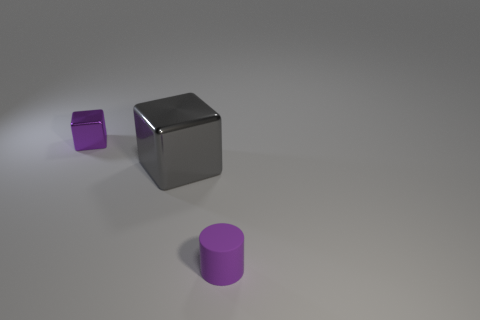How many other things are there of the same color as the tiny rubber cylinder?
Your response must be concise. 1. Are there more large things that are on the left side of the gray cube than big purple metal blocks?
Your response must be concise. No. Are the big object and the small purple block made of the same material?
Your response must be concise. Yes. How many objects are either objects that are in front of the big gray block or big metallic objects?
Keep it short and to the point. 2. How many other objects are there of the same size as the gray metallic block?
Provide a short and direct response. 0. Are there the same number of small purple objects behind the big thing and tiny purple cylinders that are behind the tiny purple cylinder?
Make the answer very short. No. What is the color of the tiny thing that is the same shape as the large object?
Offer a terse response. Purple. Are there any other things that are the same shape as the purple metal thing?
Keep it short and to the point. Yes. Is the color of the tiny object behind the small matte thing the same as the large cube?
Provide a short and direct response. No. There is another metallic object that is the same shape as the big gray shiny thing; what is its size?
Give a very brief answer. Small. 